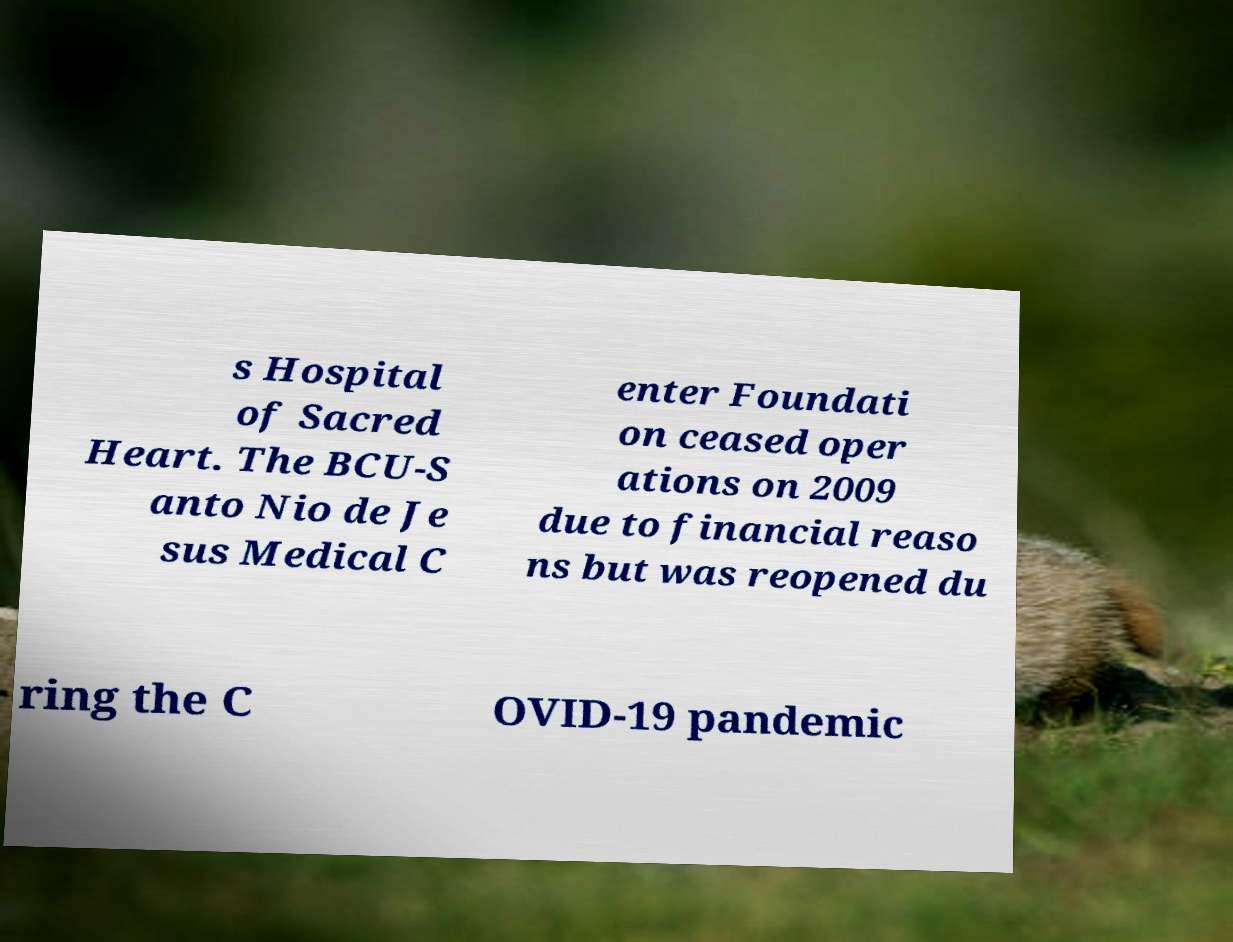Can you accurately transcribe the text from the provided image for me? s Hospital of Sacred Heart. The BCU-S anto Nio de Je sus Medical C enter Foundati on ceased oper ations on 2009 due to financial reaso ns but was reopened du ring the C OVID-19 pandemic 